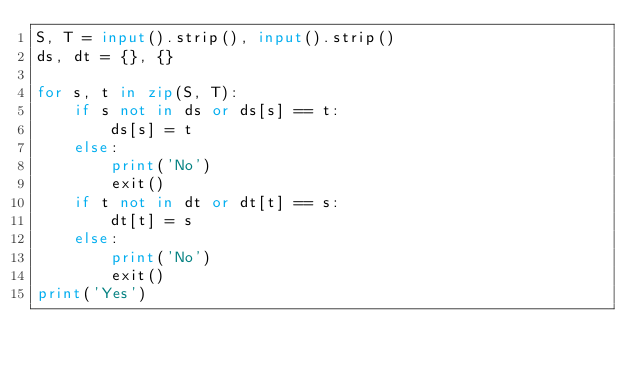Convert code to text. <code><loc_0><loc_0><loc_500><loc_500><_Python_>S, T = input().strip(), input().strip()
ds, dt = {}, {}

for s, t in zip(S, T):
    if s not in ds or ds[s] == t:
        ds[s] = t
    else:
        print('No')
        exit()
    if t not in dt or dt[t] == s:
        dt[t] = s
    else:
        print('No')
        exit()
print('Yes')</code> 